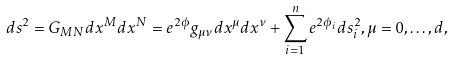Convert formula to latex. <formula><loc_0><loc_0><loc_500><loc_500>d s ^ { 2 } = G _ { M N } d x ^ { M } d x ^ { N } = e ^ { 2 \phi } g _ { \mu \nu } d x ^ { \mu } d x ^ { \nu } + \sum _ { i = 1 } ^ { n } e ^ { 2 \phi _ { i } } d s _ { i } ^ { 2 } , \mu = 0 , \dots , d ,</formula> 